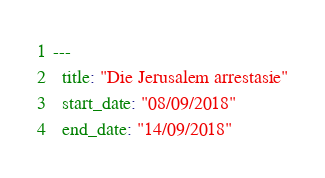<code> <loc_0><loc_0><loc_500><loc_500><_YAML_>---
  title: "Die Jerusalem arrestasie"
  start_date: "08/09/2018"
  end_date: "14/09/2018"</code> 